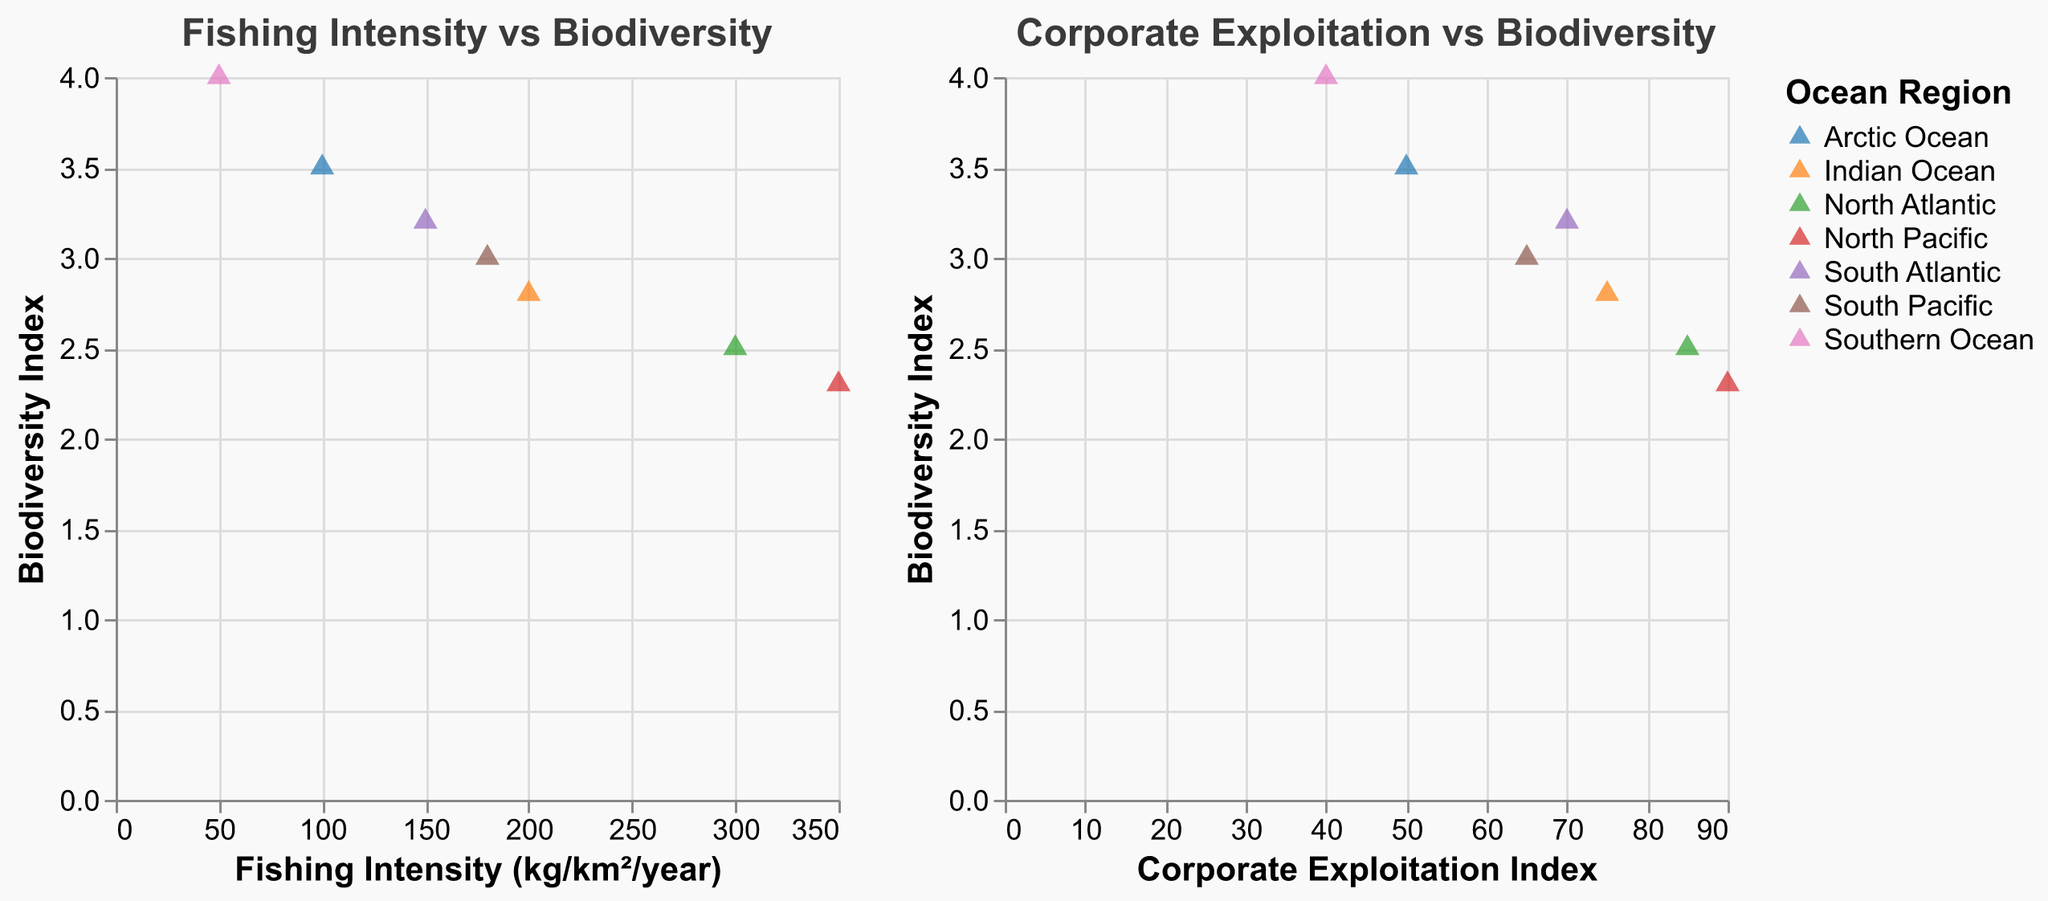What does the title of the first scatter plot indicate? The title of the first scatter plot, "Fishing Intensity vs Biodiversity," indicates that the plot shows the relationship between fishing intensity (kg/km²/year) and biodiversity index (Shannon Index) across different ocean regions.
Answer: Fishing Intensity vs Biodiversity What does the x-axis of the second scatter plot represent? The x-axis of the second scatter plot represents the Corporate Exploitation Index, which ranges from 0 to 100.
Answer: Corporate Exploitation Index Which ocean region has the highest biodiversity index and what is its value? By looking at the y-axis (Biodiversity Index) in both subplots, the Southern Ocean is seen to have the highest biodiversity index value of 4.0.
Answer: Southern Ocean, 4.0 How many data points are shown in each scatter plot? By counting the points, there are 7 data points shown in each scatter plot, representing 7 different ocean regions.
Answer: 7 Which ocean region experiences the highest fishing intensity and what is the corresponding biodiversity index? The North Pacific has the highest fishing intensity at 350 kg/km²/year. The corresponding biodiversity index for North Pacific is 2.3.
Answer: North Pacific, 2.3 Between the North Atlantic and South Atlantic, which has a higher biodiversity index and by how much? The North Atlantic has a biodiversity index of 2.5, while the South Atlantic has a biodiversity index of 3.2. The difference is 3.2 - 2.5 = 0.7.
Answer: South Atlantic, 0.7 Is there a general trend between corporate exploitation index and biodiversity index? Observing the second scatter plot, it seems that as the corporate exploitation index increases, the biodiversity index tends to decrease. For example, regions with higher exploitation indices like the North Pacific (90) show lower biodiversity indexes (2.3).
Answer: As exploitation increases, biodiversity decreases Which two ocean regions have the closest fishing intensity values, and what are those values? The Indian Ocean and South Atlantic have close fishing intensity values: 200 kg/km²/year and 150 kg/km²/year, respectively.
Answer: Indian Ocean (200), South Atlantic (150) What is the range of the biodiversity index values in the Southern Ocean, and how does it compare to those in the North Pacific? The biodiversity index in the Southern Ocean is 4.0, which is higher compared to the North Pacific's biodiversity index of 2.3.
Answer: Southern Ocean (4.0), North Pacific (2.3) 